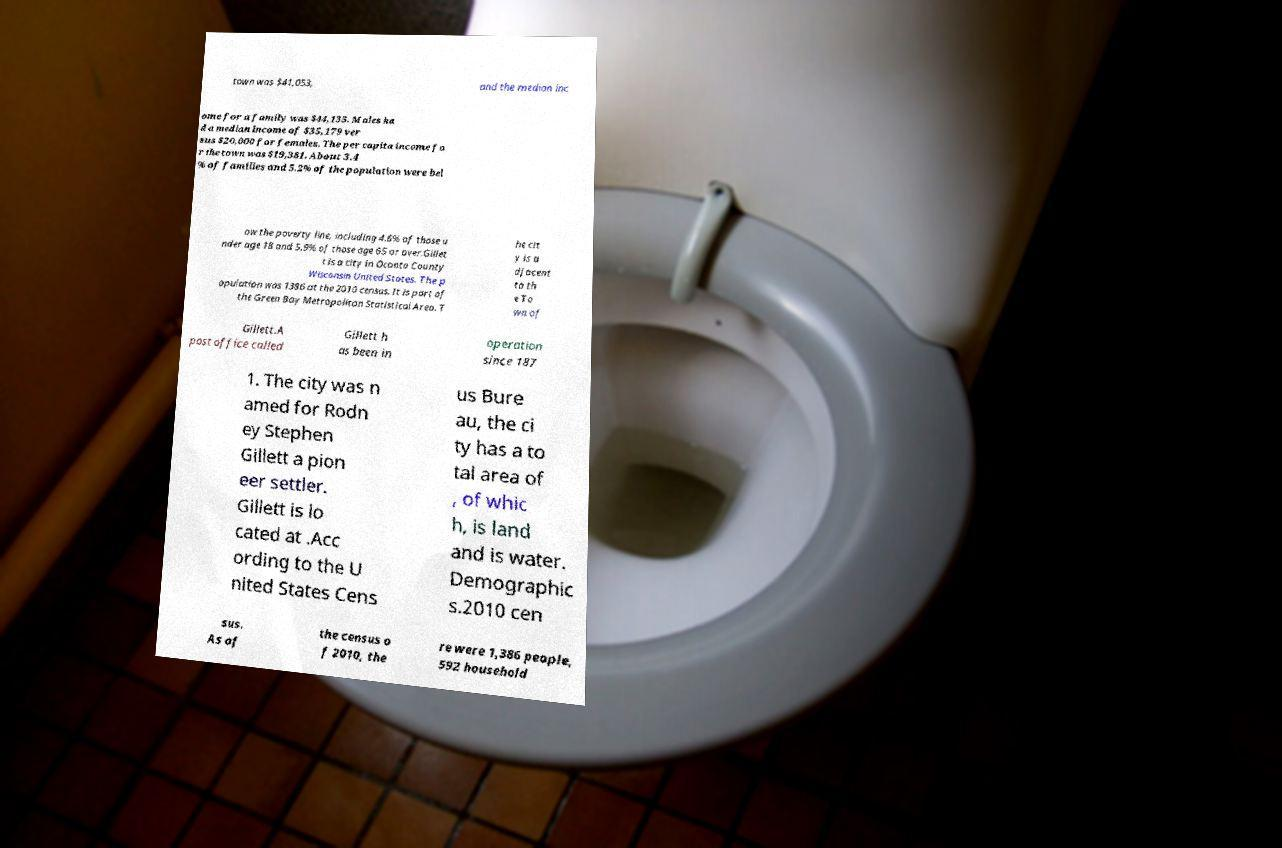Could you extract and type out the text from this image? town was $41,053, and the median inc ome for a family was $44,135. Males ha d a median income of $35,179 ver sus $20,000 for females. The per capita income fo r the town was $19,381. About 3.4 % of families and 5.2% of the population were bel ow the poverty line, including 4.6% of those u nder age 18 and 5.9% of those age 65 or over.Gillet t is a city in Oconto County Wisconsin United States. The p opulation was 1386 at the 2010 census. It is part of the Green Bay Metropolitan Statistical Area. T he cit y is a djacent to th e To wn of Gillett.A post office called Gillett h as been in operation since 187 1. The city was n amed for Rodn ey Stephen Gillett a pion eer settler. Gillett is lo cated at .Acc ording to the U nited States Cens us Bure au, the ci ty has a to tal area of , of whic h, is land and is water. Demographic s.2010 cen sus. As of the census o f 2010, the re were 1,386 people, 592 household 